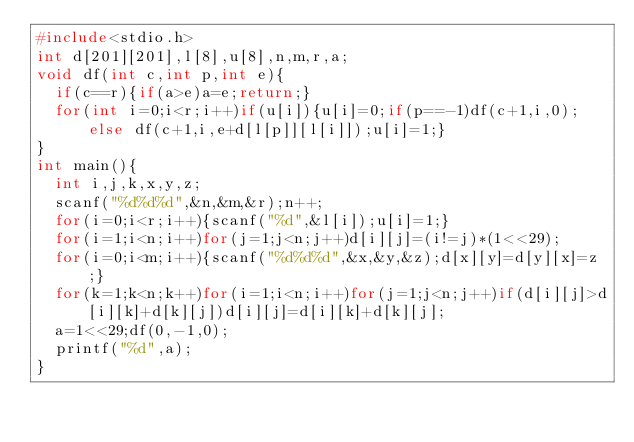Convert code to text. <code><loc_0><loc_0><loc_500><loc_500><_C_>#include<stdio.h>
int d[201][201],l[8],u[8],n,m,r,a;
void df(int c,int p,int e){
  if(c==r){if(a>e)a=e;return;}
  for(int i=0;i<r;i++)if(u[i]){u[i]=0;if(p==-1)df(c+1,i,0);else df(c+1,i,e+d[l[p]][l[i]]);u[i]=1;}
}
int main(){
  int i,j,k,x,y,z;
  scanf("%d%d%d",&n,&m,&r);n++;
  for(i=0;i<r;i++){scanf("%d",&l[i]);u[i]=1;}
  for(i=1;i<n;i++)for(j=1;j<n;j++)d[i][j]=(i!=j)*(1<<29);
  for(i=0;i<m;i++){scanf("%d%d%d",&x,&y,&z);d[x][y]=d[y][x]=z;}
  for(k=1;k<n;k++)for(i=1;i<n;i++)for(j=1;j<n;j++)if(d[i][j]>d[i][k]+d[k][j])d[i][j]=d[i][k]+d[k][j];
  a=1<<29;df(0,-1,0);
  printf("%d",a);
}
</code> 